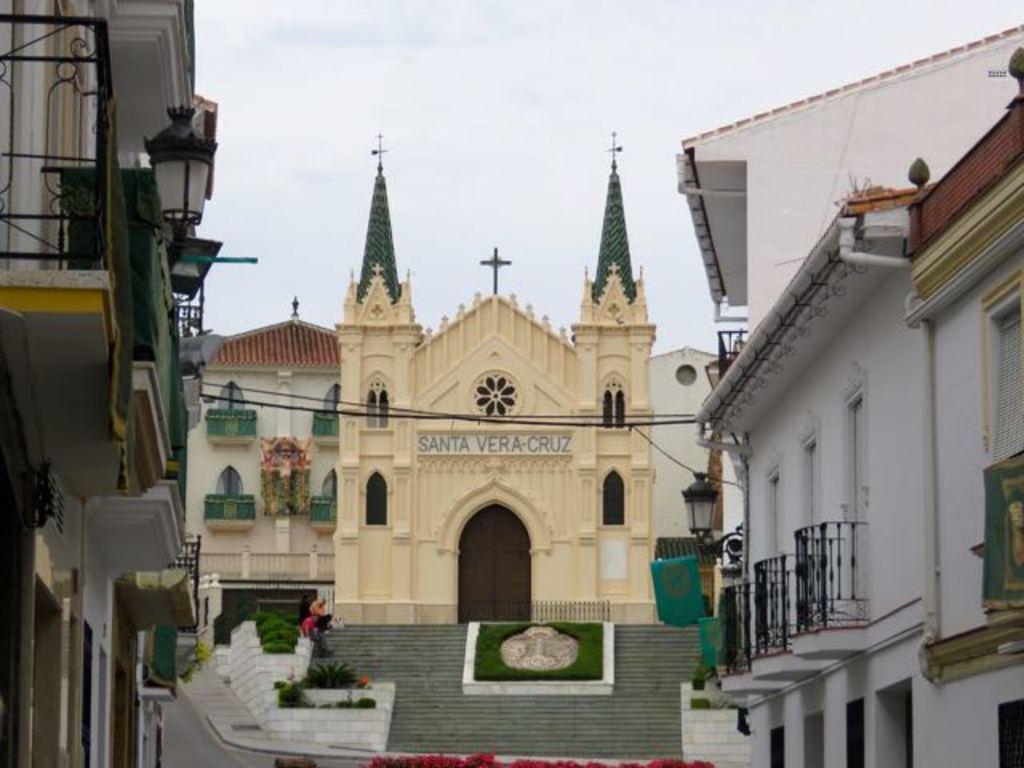How would you summarize this image in a sentence or two? In this image I can see few buildings, lights attached to the buildings and I can see few persons sitting and I can also see few cross symbols attached to the building. In the background the sky is in white color. 